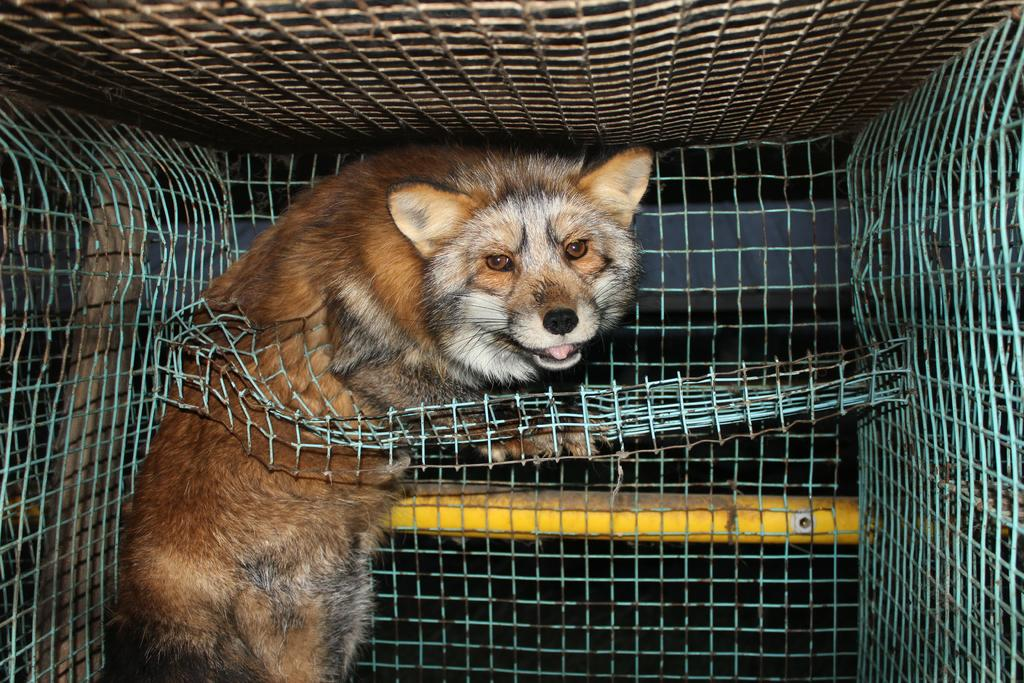What animal is present in the image? There is a fox in the image. Where is the fox located? The fox is in a closed grill fence. What other object can be seen in the image? There is a yellow color rod in the image. Are there any trails visible in the image? There is no mention of trails in the provided facts, so we cannot determine if any are present in the image. 